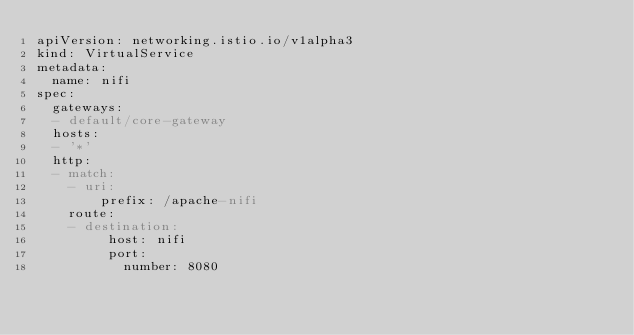<code> <loc_0><loc_0><loc_500><loc_500><_YAML_>apiVersion: networking.istio.io/v1alpha3
kind: VirtualService
metadata:
  name: nifi
spec:
  gateways:
  - default/core-gateway
  hosts:
  - '*'
  http:
  - match:
    - uri:
        prefix: /apache-nifi
    route:
    - destination:
         host: nifi
         port:
           number: 8080
</code> 